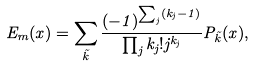Convert formula to latex. <formula><loc_0><loc_0><loc_500><loc_500>E _ { m } ( x ) = \sum _ { \vec { k } } { \frac { ( - 1 ) ^ { \sum _ { j } ( k _ { j } - 1 ) } } { \prod _ { j } k _ { j } ! j ^ { k _ { j } } } } P _ { \vec { k } } ( x ) ,</formula> 